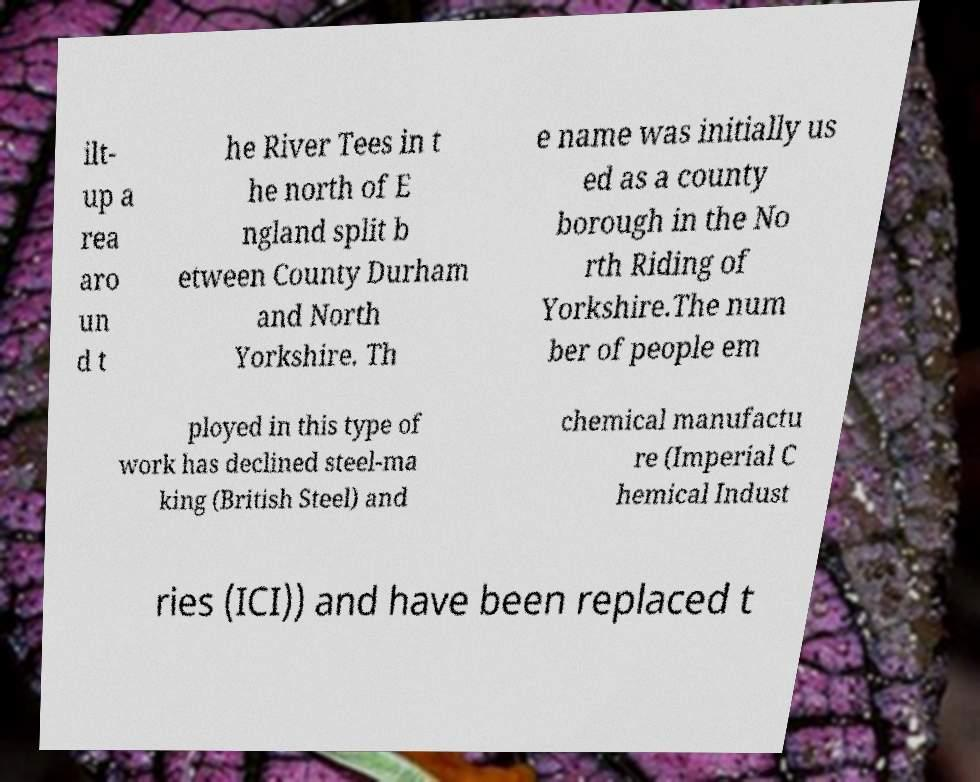Could you extract and type out the text from this image? ilt- up a rea aro un d t he River Tees in t he north of E ngland split b etween County Durham and North Yorkshire. Th e name was initially us ed as a county borough in the No rth Riding of Yorkshire.The num ber of people em ployed in this type of work has declined steel-ma king (British Steel) and chemical manufactu re (Imperial C hemical Indust ries (ICI)) and have been replaced t 